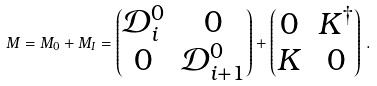<formula> <loc_0><loc_0><loc_500><loc_500>M = M _ { 0 } + M _ { I } = \begin{pmatrix} \mathcal { D } _ { i } ^ { 0 } & 0 \\ 0 & \mathcal { D } _ { i + 1 } ^ { 0 } \end{pmatrix} + \begin{pmatrix} 0 & K ^ { \dagger } \\ K & 0 \end{pmatrix} \, .</formula> 